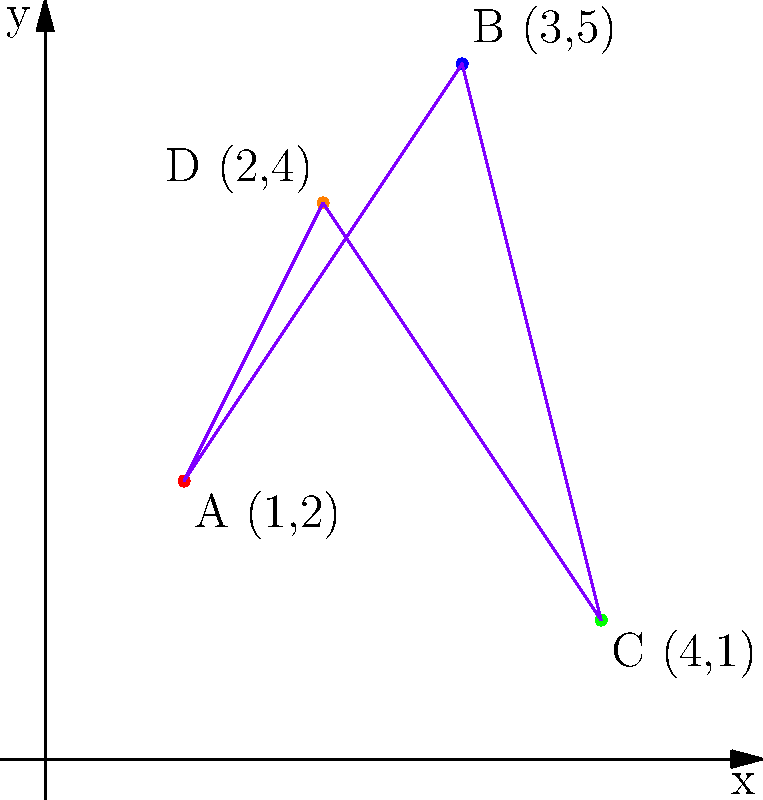As a hospitality manager overseeing new commercial developments, you're analyzing the locations of four new properties on a coordinate system. The properties are represented by points A(1,2), B(3,5), C(4,1), and D(2,4). What is the area of the quadrilateral formed by connecting these four points in the order they're listed? To find the area of the quadrilateral, we can use the Shoelace formula (also known as the surveyor's formula). This method is particularly useful for irregular polygons plotted on a coordinate system.

The Shoelace formula for a quadrilateral with vertices $(x_1, y_1)$, $(x_2, y_2)$, $(x_3, y_3)$, and $(x_4, y_4)$ is:

$$Area = \frac{1}{2}|(x_1y_2 + x_2y_3 + x_3y_4 + x_4y_1) - (y_1x_2 + y_2x_3 + y_3x_4 + y_4x_1)|$$

Let's substitute our points:
A(1,2), B(3,5), C(4,1), D(2,4)

$$Area = \frac{1}{2}|(1 \cdot 5 + 3 \cdot 1 + 4 \cdot 4 + 2 \cdot 2) - (2 \cdot 3 + 5 \cdot 4 + 1 \cdot 2 + 4 \cdot 1)|$$

$$Area = \frac{1}{2}|(5 + 3 + 16 + 4) - (6 + 20 + 2 + 4)|$$

$$Area = \frac{1}{2}|28 - 32|$$

$$Area = \frac{1}{2} \cdot 4 = 2$$

Therefore, the area of the quadrilateral is 2 square units.
Answer: 2 square units 